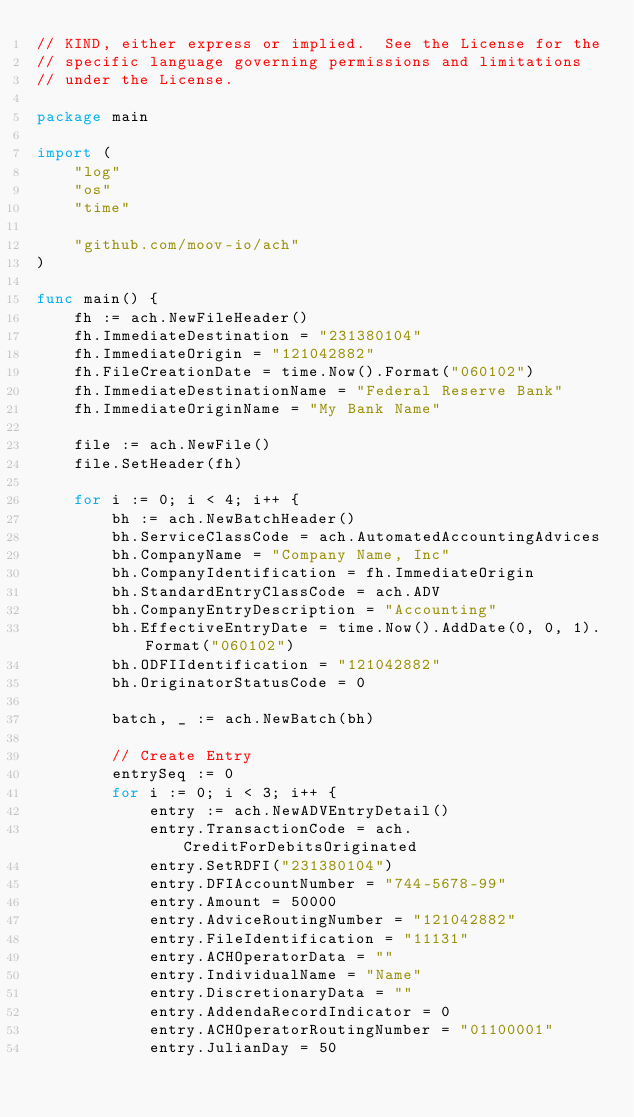<code> <loc_0><loc_0><loc_500><loc_500><_Go_>// KIND, either express or implied.  See the License for the
// specific language governing permissions and limitations
// under the License.

package main

import (
	"log"
	"os"
	"time"

	"github.com/moov-io/ach"
)

func main() {
	fh := ach.NewFileHeader()
	fh.ImmediateDestination = "231380104"
	fh.ImmediateOrigin = "121042882"
	fh.FileCreationDate = time.Now().Format("060102")
	fh.ImmediateDestinationName = "Federal Reserve Bank"
	fh.ImmediateOriginName = "My Bank Name"

	file := ach.NewFile()
	file.SetHeader(fh)

	for i := 0; i < 4; i++ {
		bh := ach.NewBatchHeader()
		bh.ServiceClassCode = ach.AutomatedAccountingAdvices
		bh.CompanyName = "Company Name, Inc"
		bh.CompanyIdentification = fh.ImmediateOrigin
		bh.StandardEntryClassCode = ach.ADV
		bh.CompanyEntryDescription = "Accounting"
		bh.EffectiveEntryDate = time.Now().AddDate(0, 0, 1).Format("060102")
		bh.ODFIIdentification = "121042882"
		bh.OriginatorStatusCode = 0

		batch, _ := ach.NewBatch(bh)

		// Create Entry
		entrySeq := 0
		for i := 0; i < 3; i++ {
			entry := ach.NewADVEntryDetail()
			entry.TransactionCode = ach.CreditForDebitsOriginated
			entry.SetRDFI("231380104")
			entry.DFIAccountNumber = "744-5678-99"
			entry.Amount = 50000
			entry.AdviceRoutingNumber = "121042882"
			entry.FileIdentification = "11131"
			entry.ACHOperatorData = ""
			entry.IndividualName = "Name"
			entry.DiscretionaryData = ""
			entry.AddendaRecordIndicator = 0
			entry.ACHOperatorRoutingNumber = "01100001"
			entry.JulianDay = 50</code> 